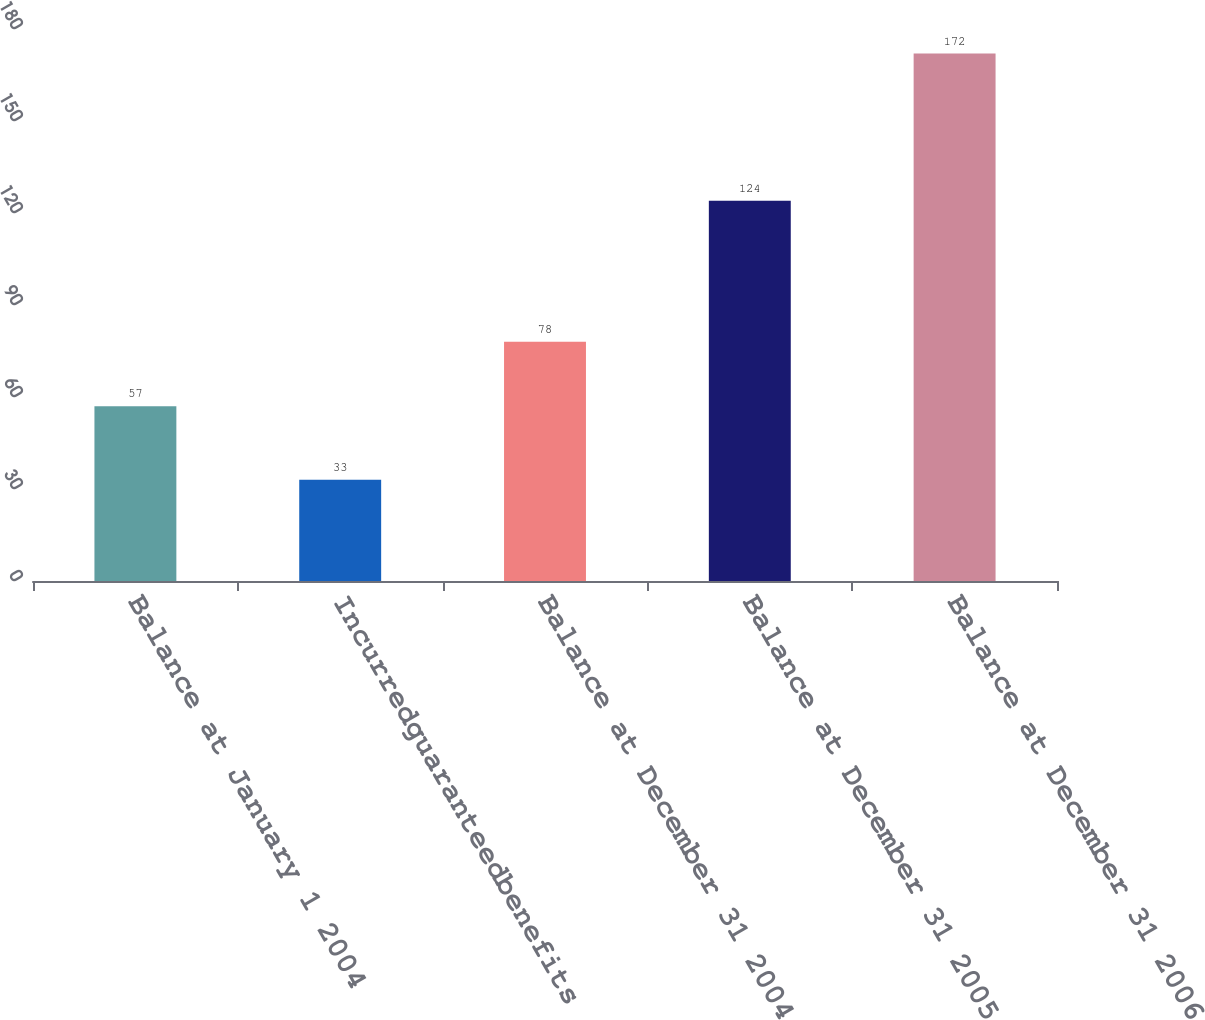<chart> <loc_0><loc_0><loc_500><loc_500><bar_chart><fcel>Balance at January 1 2004<fcel>Incurredguaranteedbenefits<fcel>Balance at December 31 2004<fcel>Balance at December 31 2005<fcel>Balance at December 31 2006<nl><fcel>57<fcel>33<fcel>78<fcel>124<fcel>172<nl></chart> 